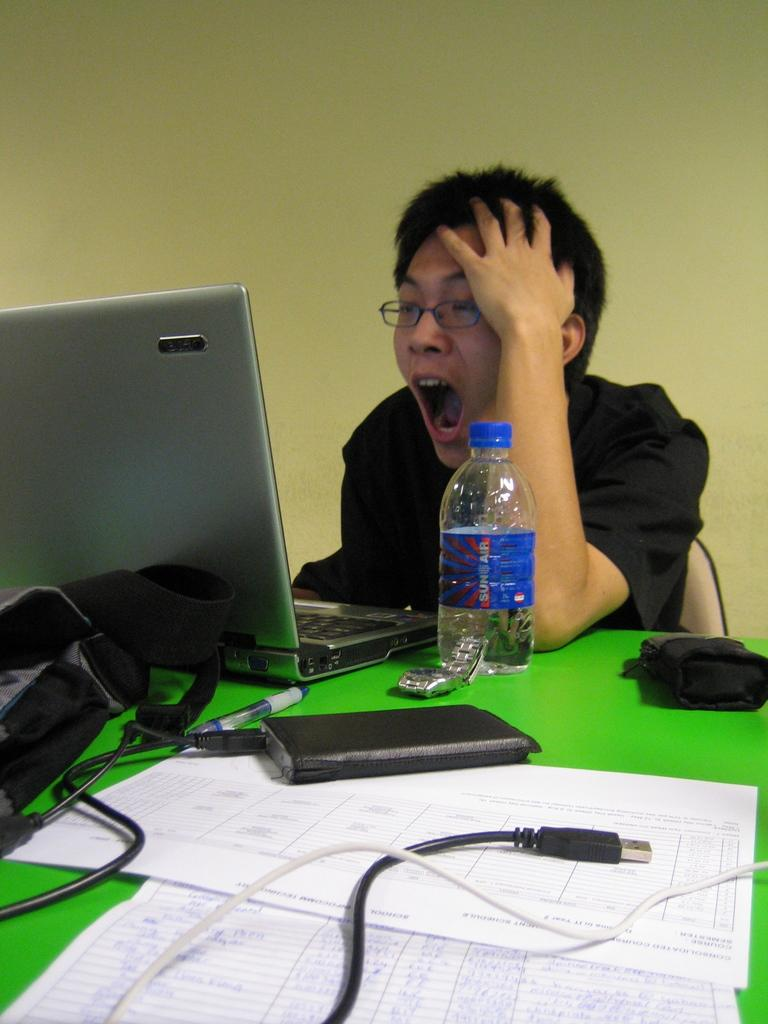What is the person in the image doing? The person is seated on a chair and working with a laptop. What is located in front of the person? There is a bottle and some objects in front of the person. What type of territory can be seen in the background of the image? There is no territory visible in the image; it only shows a person seated on a chair and working with a laptop. How many roads are visible in the image? There are no roads visible in the image. 